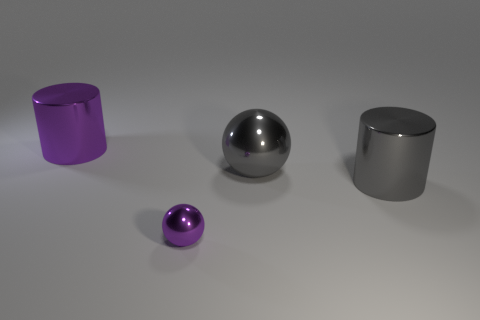Is there anything else that has the same size as the purple metallic ball?
Give a very brief answer. No. How many gray shiny things are the same shape as the large purple shiny thing?
Provide a short and direct response. 1. There is a gray thing that is made of the same material as the gray cylinder; what size is it?
Provide a succinct answer. Large. Is the number of purple metallic things greater than the number of large gray metallic blocks?
Your answer should be compact. Yes. What color is the metal ball that is behind the tiny shiny object?
Give a very brief answer. Gray. There is a shiny object that is both behind the gray cylinder and to the left of the large gray shiny ball; what is its size?
Provide a succinct answer. Large. How many gray cylinders have the same size as the gray ball?
Your response must be concise. 1. There is another thing that is the same shape as the tiny metal object; what material is it?
Make the answer very short. Metal. Is the tiny object the same shape as the large purple shiny object?
Your answer should be very brief. No. There is a tiny purple sphere; what number of big metal things are to the left of it?
Keep it short and to the point. 1. 